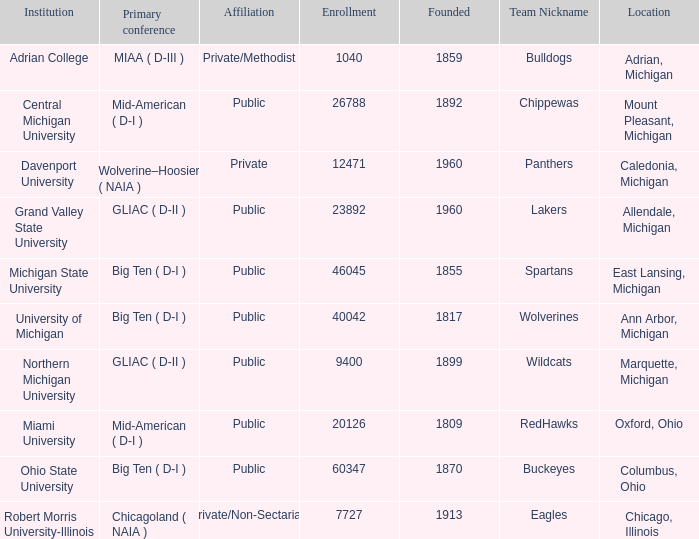What is the nickname of the Adrian, Michigan team? Bulldogs. 